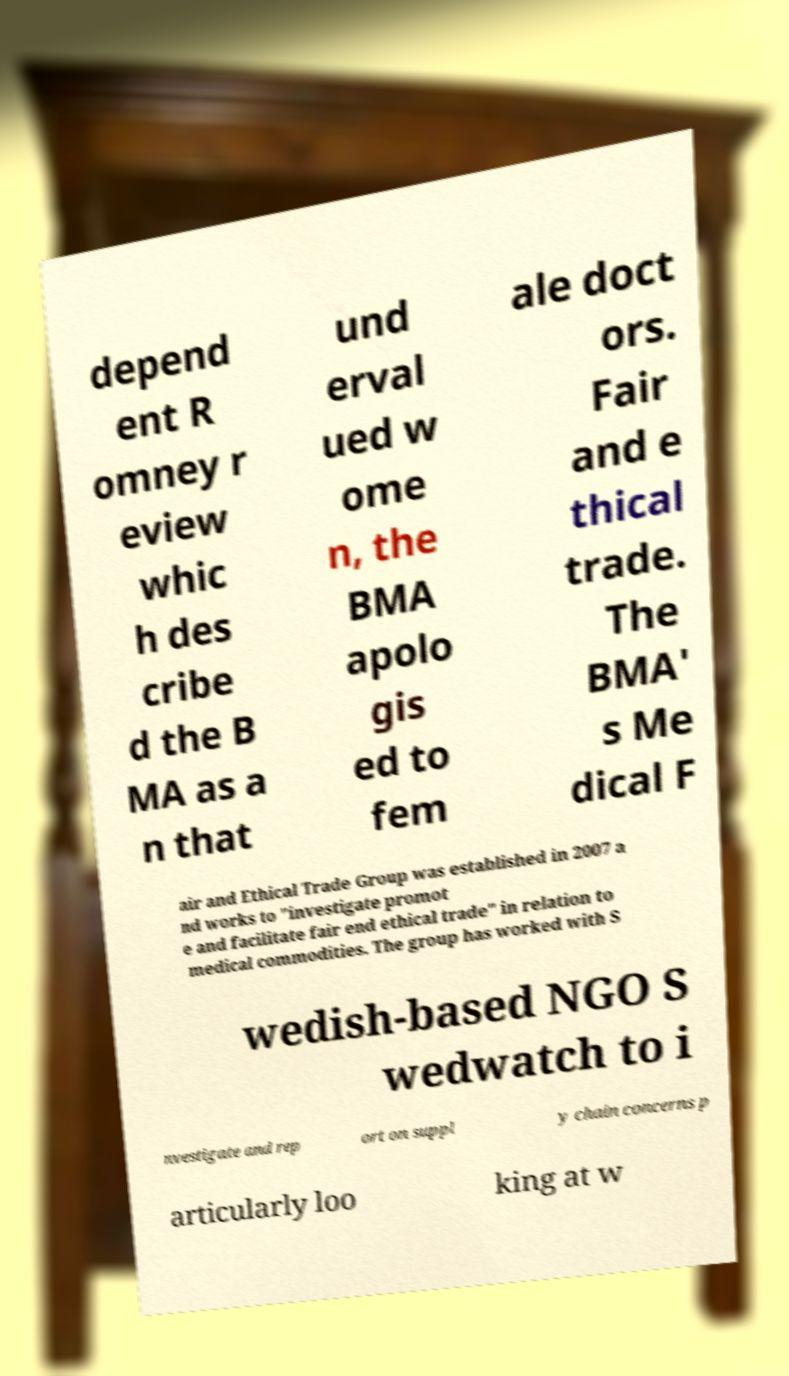There's text embedded in this image that I need extracted. Can you transcribe it verbatim? depend ent R omney r eview whic h des cribe d the B MA as a n that und erval ued w ome n, the BMA apolo gis ed to fem ale doct ors. Fair and e thical trade. The BMA' s Me dical F air and Ethical Trade Group was established in 2007 a nd works to "investigate promot e and facilitate fair end ethical trade" in relation to medical commodities. The group has worked with S wedish-based NGO S wedwatch to i nvestigate and rep ort on suppl y chain concerns p articularly loo king at w 